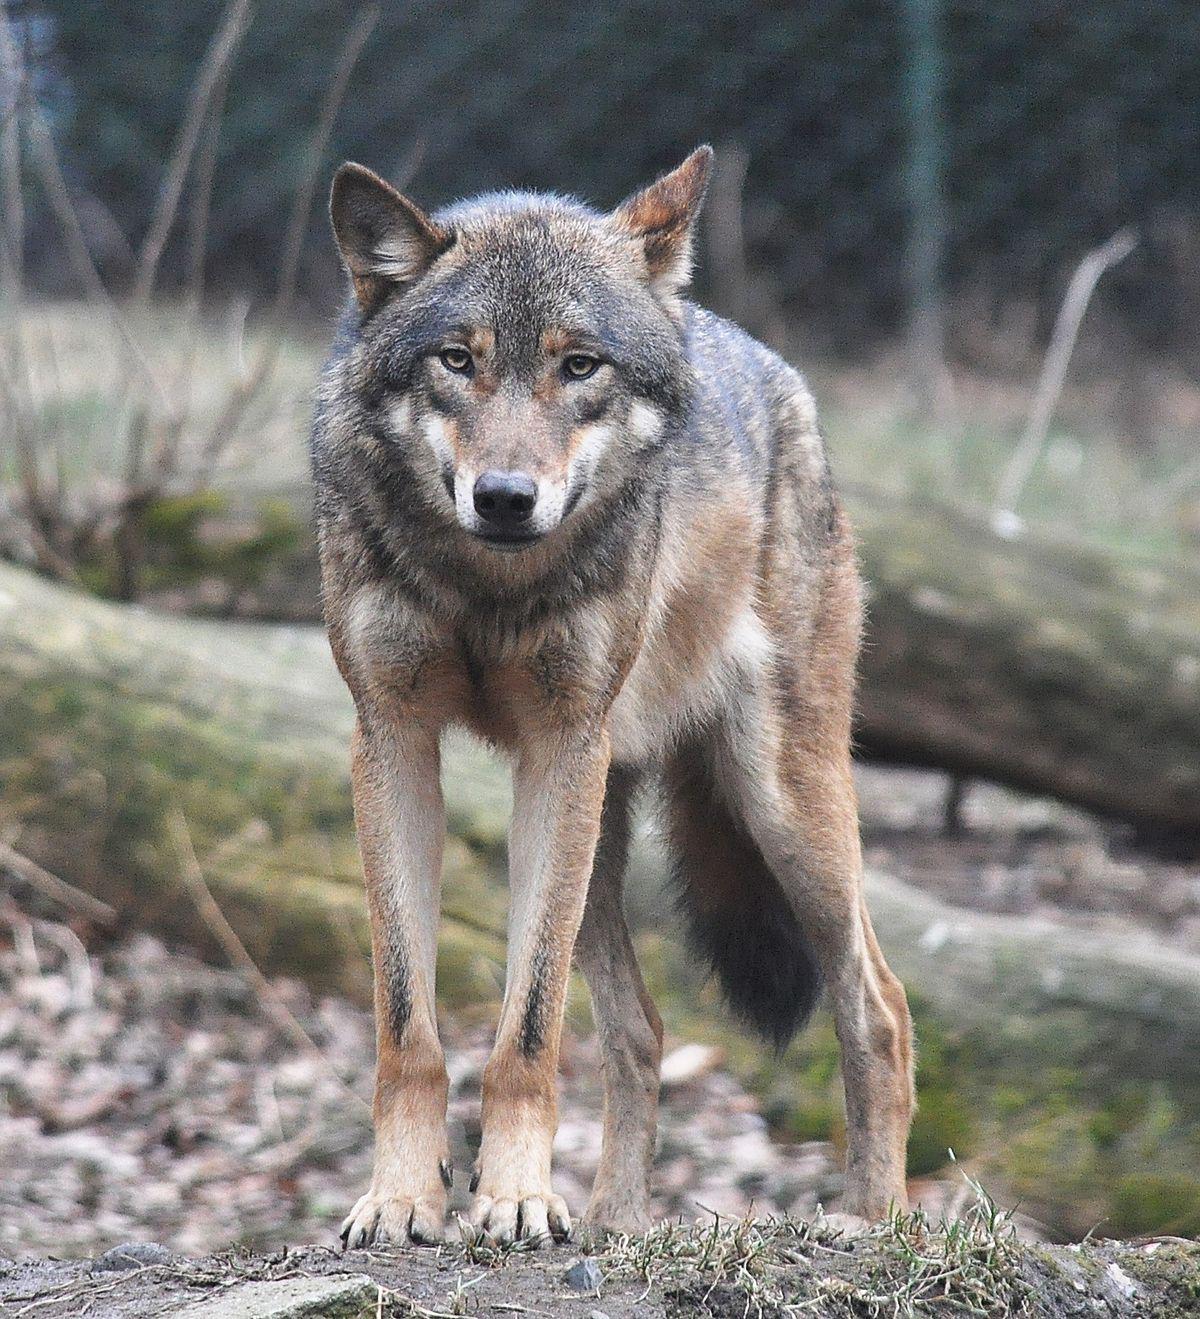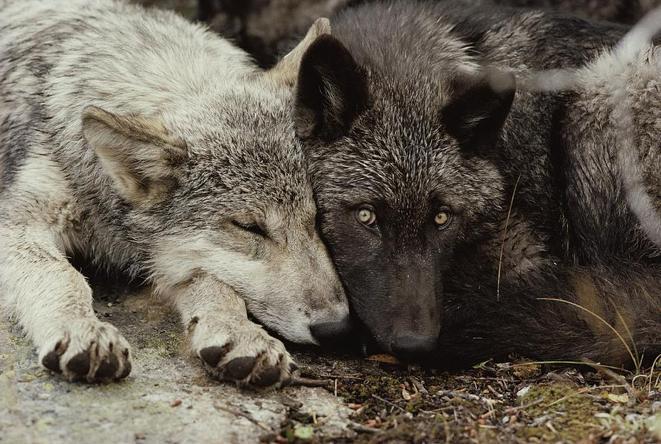The first image is the image on the left, the second image is the image on the right. Given the left and right images, does the statement "In one of the pictures, two wolves are cuddling, and in the other, a wolf is alone and there is a tree or tree bark visible." hold true? Answer yes or no. Yes. 